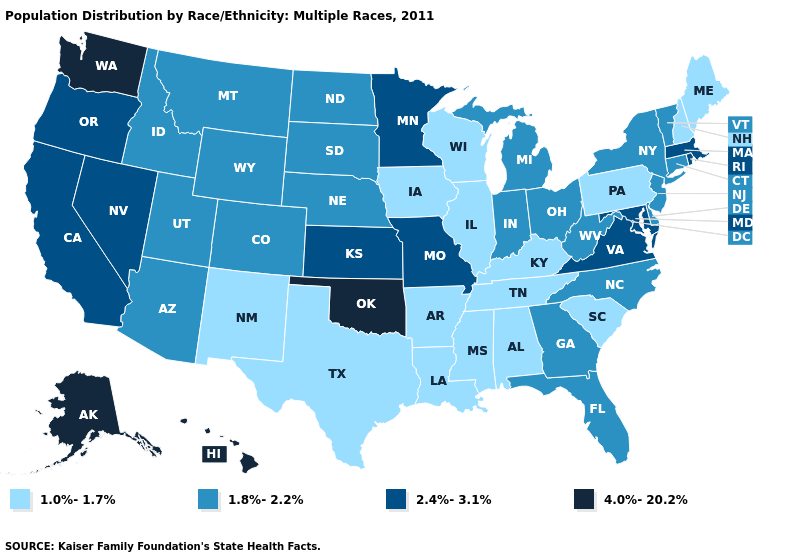Name the states that have a value in the range 4.0%-20.2%?
Keep it brief. Alaska, Hawaii, Oklahoma, Washington. What is the value of California?
Quick response, please. 2.4%-3.1%. What is the value of West Virginia?
Quick response, please. 1.8%-2.2%. What is the value of Illinois?
Write a very short answer. 1.0%-1.7%. Name the states that have a value in the range 2.4%-3.1%?
Quick response, please. California, Kansas, Maryland, Massachusetts, Minnesota, Missouri, Nevada, Oregon, Rhode Island, Virginia. Name the states that have a value in the range 1.8%-2.2%?
Quick response, please. Arizona, Colorado, Connecticut, Delaware, Florida, Georgia, Idaho, Indiana, Michigan, Montana, Nebraska, New Jersey, New York, North Carolina, North Dakota, Ohio, South Dakota, Utah, Vermont, West Virginia, Wyoming. Does Kentucky have the highest value in the USA?
Be succinct. No. What is the value of Tennessee?
Concise answer only. 1.0%-1.7%. What is the highest value in states that border Pennsylvania?
Be succinct. 2.4%-3.1%. Does New York have the lowest value in the Northeast?
Short answer required. No. Which states have the lowest value in the USA?
Concise answer only. Alabama, Arkansas, Illinois, Iowa, Kentucky, Louisiana, Maine, Mississippi, New Hampshire, New Mexico, Pennsylvania, South Carolina, Tennessee, Texas, Wisconsin. Which states hav the highest value in the South?
Keep it brief. Oklahoma. Which states have the lowest value in the South?
Quick response, please. Alabama, Arkansas, Kentucky, Louisiana, Mississippi, South Carolina, Tennessee, Texas. What is the value of Louisiana?
Quick response, please. 1.0%-1.7%. 